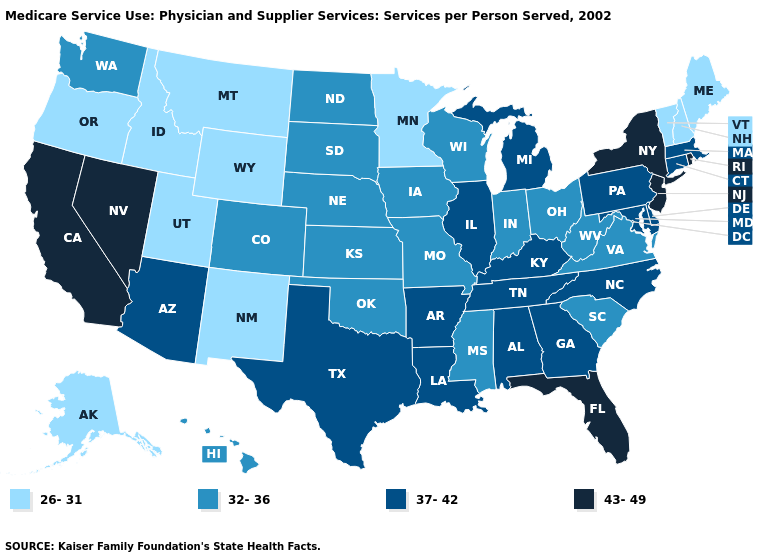What is the value of Arizona?
Answer briefly. 37-42. What is the lowest value in states that border Ohio?
Give a very brief answer. 32-36. Name the states that have a value in the range 43-49?
Short answer required. California, Florida, Nevada, New Jersey, New York, Rhode Island. Name the states that have a value in the range 37-42?
Be succinct. Alabama, Arizona, Arkansas, Connecticut, Delaware, Georgia, Illinois, Kentucky, Louisiana, Maryland, Massachusetts, Michigan, North Carolina, Pennsylvania, Tennessee, Texas. What is the lowest value in the MidWest?
Answer briefly. 26-31. What is the value of Indiana?
Concise answer only. 32-36. Among the states that border Ohio , which have the highest value?
Concise answer only. Kentucky, Michigan, Pennsylvania. What is the value of North Carolina?
Write a very short answer. 37-42. What is the lowest value in the USA?
Write a very short answer. 26-31. Name the states that have a value in the range 26-31?
Be succinct. Alaska, Idaho, Maine, Minnesota, Montana, New Hampshire, New Mexico, Oregon, Utah, Vermont, Wyoming. Does New Mexico have the lowest value in the USA?
Give a very brief answer. Yes. What is the highest value in states that border Wyoming?
Answer briefly. 32-36. Among the states that border Georgia , does North Carolina have the lowest value?
Give a very brief answer. No. Which states hav the highest value in the South?
Keep it brief. Florida. 